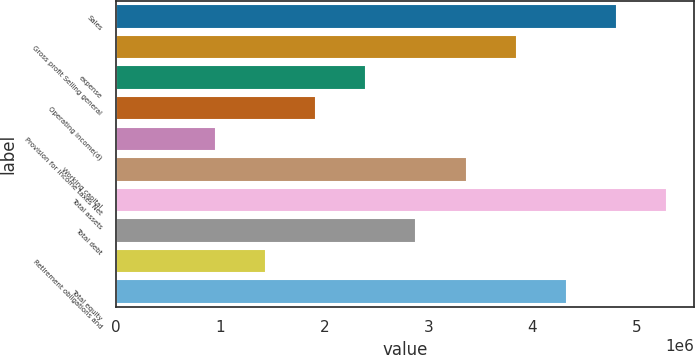Convert chart to OTSL. <chart><loc_0><loc_0><loc_500><loc_500><bar_chart><fcel>Sales<fcel>Gross profit Selling general<fcel>expense<fcel>Operating income(d)<fcel>Provision for income taxes Net<fcel>Working capital<fcel>Total assets<fcel>Total debt<fcel>Retirement obligations and<fcel>Total equity<nl><fcel>4.81096e+06<fcel>3.84877e+06<fcel>2.40549e+06<fcel>1.92439e+06<fcel>962205<fcel>3.36768e+06<fcel>5.29205e+06<fcel>2.88658e+06<fcel>1.4433e+06<fcel>4.32986e+06<nl></chart> 